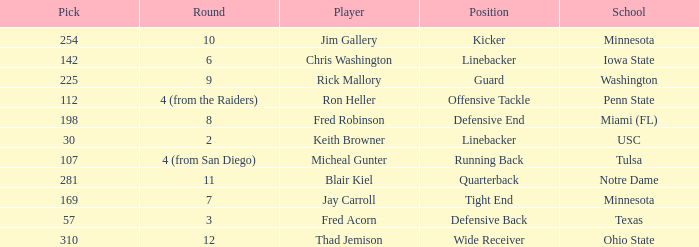Which Round is pick 112 in? 4 (from the Raiders). Help me parse the entirety of this table. {'header': ['Pick', 'Round', 'Player', 'Position', 'School'], 'rows': [['254', '10', 'Jim Gallery', 'Kicker', 'Minnesota'], ['142', '6', 'Chris Washington', 'Linebacker', 'Iowa State'], ['225', '9', 'Rick Mallory', 'Guard', 'Washington'], ['112', '4 (from the Raiders)', 'Ron Heller', 'Offensive Tackle', 'Penn State'], ['198', '8', 'Fred Robinson', 'Defensive End', 'Miami (FL)'], ['30', '2', 'Keith Browner', 'Linebacker', 'USC'], ['107', '4 (from San Diego)', 'Micheal Gunter', 'Running Back', 'Tulsa'], ['281', '11', 'Blair Kiel', 'Quarterback', 'Notre Dame'], ['169', '7', 'Jay Carroll', 'Tight End', 'Minnesota'], ['57', '3', 'Fred Acorn', 'Defensive Back', 'Texas'], ['310', '12', 'Thad Jemison', 'Wide Receiver', 'Ohio State']]} 